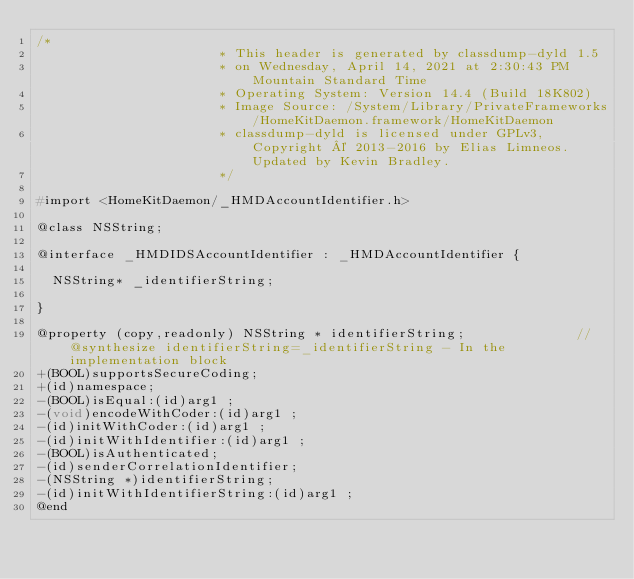<code> <loc_0><loc_0><loc_500><loc_500><_C_>/*
                       * This header is generated by classdump-dyld 1.5
                       * on Wednesday, April 14, 2021 at 2:30:43 PM Mountain Standard Time
                       * Operating System: Version 14.4 (Build 18K802)
                       * Image Source: /System/Library/PrivateFrameworks/HomeKitDaemon.framework/HomeKitDaemon
                       * classdump-dyld is licensed under GPLv3, Copyright © 2013-2016 by Elias Limneos. Updated by Kevin Bradley.
                       */

#import <HomeKitDaemon/_HMDAccountIdentifier.h>

@class NSString;

@interface _HMDIDSAccountIdentifier : _HMDAccountIdentifier {

	NSString* _identifierString;

}

@property (copy,readonly) NSString * identifierString;              //@synthesize identifierString=_identifierString - In the implementation block
+(BOOL)supportsSecureCoding;
+(id)namespace;
-(BOOL)isEqual:(id)arg1 ;
-(void)encodeWithCoder:(id)arg1 ;
-(id)initWithCoder:(id)arg1 ;
-(id)initWithIdentifier:(id)arg1 ;
-(BOOL)isAuthenticated;
-(id)senderCorrelationIdentifier;
-(NSString *)identifierString;
-(id)initWithIdentifierString:(id)arg1 ;
@end

</code> 